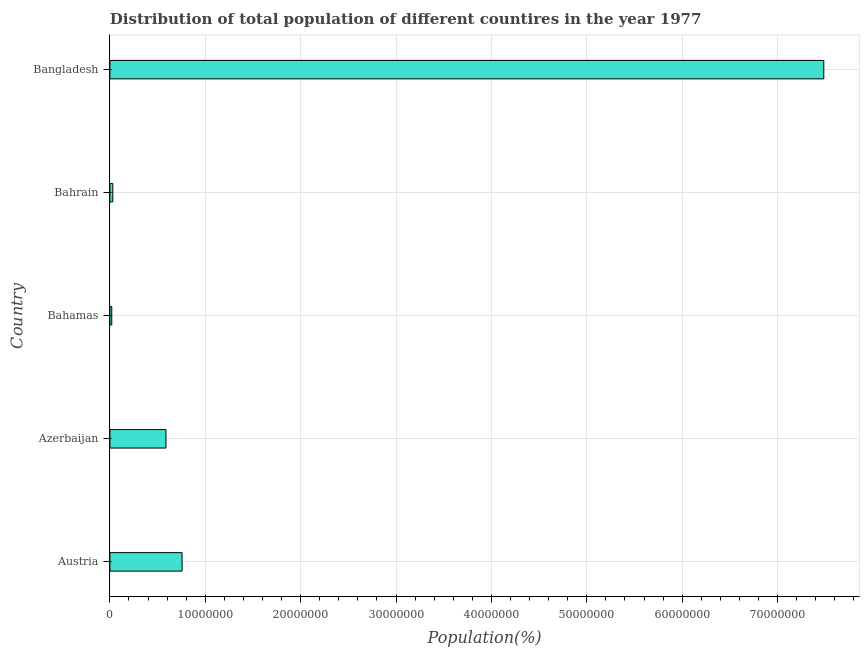Does the graph contain grids?
Make the answer very short. Yes. What is the title of the graph?
Give a very brief answer. Distribution of total population of different countires in the year 1977. What is the label or title of the X-axis?
Your answer should be very brief. Population(%). What is the population in Bahrain?
Give a very brief answer. 3.03e+05. Across all countries, what is the maximum population?
Offer a terse response. 7.48e+07. Across all countries, what is the minimum population?
Provide a short and direct response. 1.97e+05. In which country was the population minimum?
Your response must be concise. Bahamas. What is the sum of the population?
Make the answer very short. 8.88e+07. What is the difference between the population in Austria and Bahamas?
Your answer should be compact. 7.37e+06. What is the average population per country?
Your response must be concise. 1.78e+07. What is the median population?
Your answer should be compact. 5.88e+06. In how many countries, is the population greater than 8000000 %?
Give a very brief answer. 1. What is the ratio of the population in Austria to that in Bangladesh?
Offer a terse response. 0.1. Is the population in Austria less than that in Bahamas?
Make the answer very short. No. Is the difference between the population in Bahamas and Bangladesh greater than the difference between any two countries?
Provide a succinct answer. Yes. What is the difference between the highest and the second highest population?
Ensure brevity in your answer.  6.73e+07. What is the difference between the highest and the lowest population?
Keep it short and to the point. 7.47e+07. Are the values on the major ticks of X-axis written in scientific E-notation?
Ensure brevity in your answer.  No. What is the Population(%) of Austria?
Your answer should be very brief. 7.57e+06. What is the Population(%) of Azerbaijan?
Your response must be concise. 5.88e+06. What is the Population(%) of Bahamas?
Offer a very short reply. 1.97e+05. What is the Population(%) of Bahrain?
Make the answer very short. 3.03e+05. What is the Population(%) of Bangladesh?
Provide a succinct answer. 7.48e+07. What is the difference between the Population(%) in Austria and Azerbaijan?
Your answer should be compact. 1.69e+06. What is the difference between the Population(%) in Austria and Bahamas?
Offer a very short reply. 7.37e+06. What is the difference between the Population(%) in Austria and Bahrain?
Offer a terse response. 7.27e+06. What is the difference between the Population(%) in Austria and Bangladesh?
Keep it short and to the point. -6.73e+07. What is the difference between the Population(%) in Azerbaijan and Bahamas?
Keep it short and to the point. 5.69e+06. What is the difference between the Population(%) in Azerbaijan and Bahrain?
Provide a succinct answer. 5.58e+06. What is the difference between the Population(%) in Azerbaijan and Bangladesh?
Give a very brief answer. -6.90e+07. What is the difference between the Population(%) in Bahamas and Bahrain?
Keep it short and to the point. -1.06e+05. What is the difference between the Population(%) in Bahamas and Bangladesh?
Keep it short and to the point. -7.47e+07. What is the difference between the Population(%) in Bahrain and Bangladesh?
Provide a short and direct response. -7.45e+07. What is the ratio of the Population(%) in Austria to that in Azerbaijan?
Provide a succinct answer. 1.29. What is the ratio of the Population(%) in Austria to that in Bahamas?
Make the answer very short. 38.4. What is the ratio of the Population(%) in Austria to that in Bahrain?
Keep it short and to the point. 24.96. What is the ratio of the Population(%) in Austria to that in Bangladesh?
Offer a very short reply. 0.1. What is the ratio of the Population(%) in Azerbaijan to that in Bahamas?
Offer a very short reply. 29.84. What is the ratio of the Population(%) in Azerbaijan to that in Bahrain?
Keep it short and to the point. 19.4. What is the ratio of the Population(%) in Azerbaijan to that in Bangladesh?
Offer a terse response. 0.08. What is the ratio of the Population(%) in Bahamas to that in Bahrain?
Offer a very short reply. 0.65. What is the ratio of the Population(%) in Bahamas to that in Bangladesh?
Your answer should be very brief. 0. What is the ratio of the Population(%) in Bahrain to that in Bangladesh?
Provide a succinct answer. 0. 